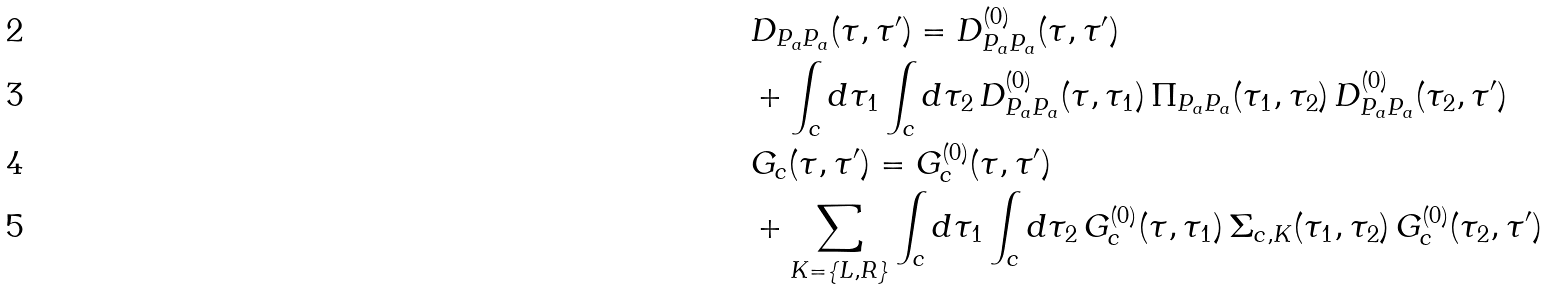<formula> <loc_0><loc_0><loc_500><loc_500>& D _ { P _ { a } P _ { a } } ( \tau , \tau ^ { \prime } ) = D _ { P _ { a } P _ { a } } ^ { ( 0 ) } ( \tau , \tau ^ { \prime } ) \\ & + \int _ { c } d \tau _ { 1 } \int _ { c } d \tau _ { 2 } \, D _ { P _ { a } P _ { a } } ^ { ( 0 ) } ( \tau , \tau _ { 1 } ) \, \Pi _ { P _ { a } P _ { a } } ( \tau _ { 1 } , \tau _ { 2 } ) \, D _ { P _ { a } P _ { a } } ^ { ( 0 ) } ( \tau _ { 2 } , \tau ^ { \prime } ) \\ & G _ { c } ( \tau , \tau ^ { \prime } ) = G _ { c } ^ { ( 0 ) } ( \tau , \tau ^ { \prime } ) \\ & + \sum _ { K = \{ L , R \} } \int _ { c } d \tau _ { 1 } \int _ { c } d \tau _ { 2 } \, G _ { c } ^ { ( 0 ) } ( \tau , \tau _ { 1 } ) \, \Sigma _ { c , K } ( \tau _ { 1 } , \tau _ { 2 } ) \, G _ { c } ^ { ( 0 ) } ( \tau _ { 2 } , \tau ^ { \prime } )</formula> 